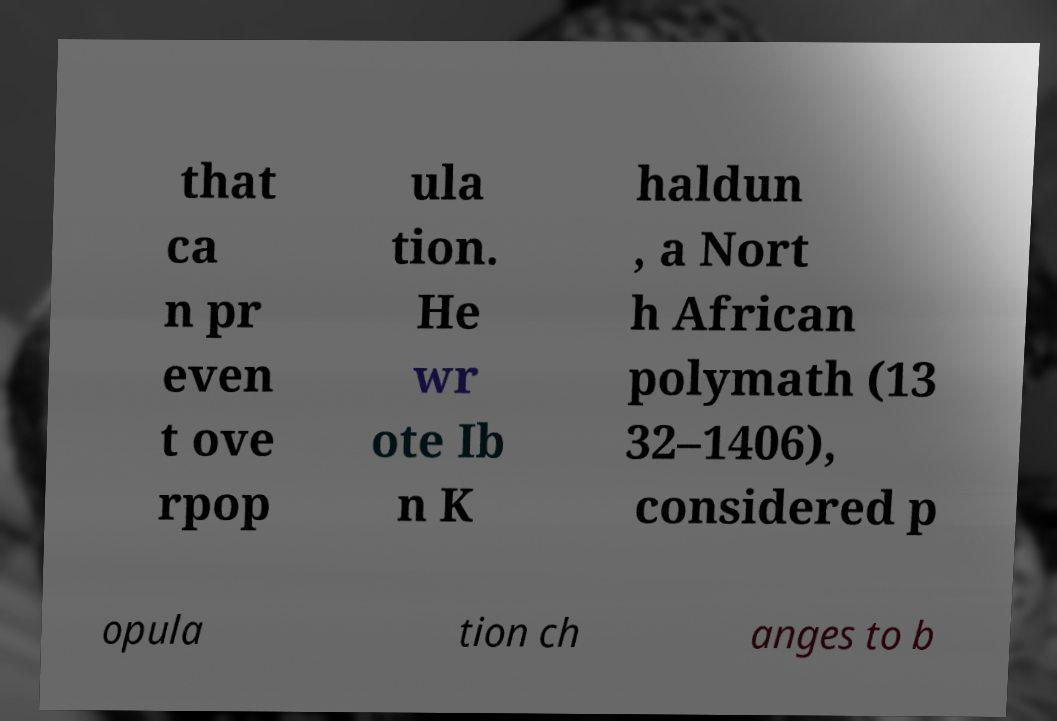What messages or text are displayed in this image? I need them in a readable, typed format. that ca n pr even t ove rpop ula tion. He wr ote Ib n K haldun , a Nort h African polymath (13 32–1406), considered p opula tion ch anges to b 